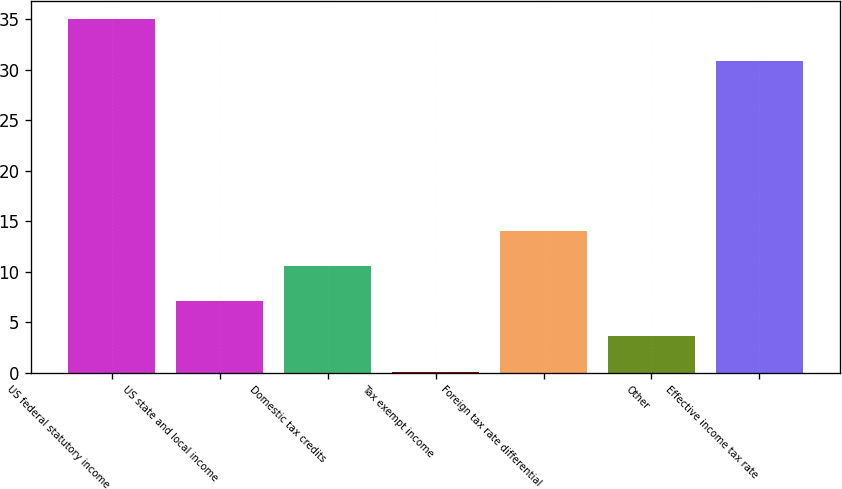Convert chart to OTSL. <chart><loc_0><loc_0><loc_500><loc_500><bar_chart><fcel>US federal statutory income<fcel>US state and local income<fcel>Domestic tax credits<fcel>Tax exempt income<fcel>Foreign tax rate differential<fcel>Other<fcel>Effective income tax rate<nl><fcel>35<fcel>7.08<fcel>10.57<fcel>0.1<fcel>14.06<fcel>3.59<fcel>30.8<nl></chart> 